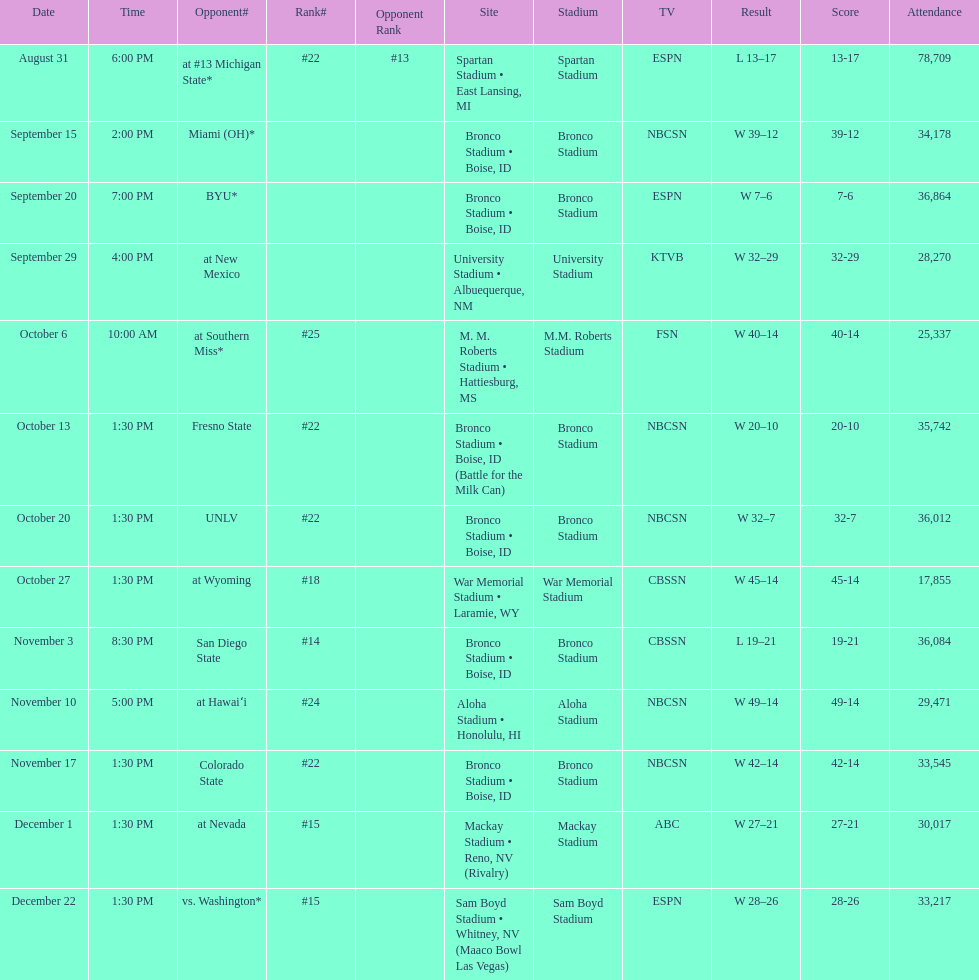What was there top ranked position of the season? #14. 